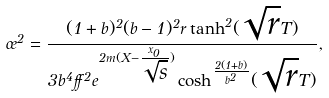<formula> <loc_0><loc_0><loc_500><loc_500>\sigma ^ { 2 } = \frac { ( 1 + b ) ^ { 2 } ( b - 1 ) ^ { 2 } r \tanh ^ { 2 } ( \sqrt { r } T ) } { 3 b ^ { 4 } \alpha ^ { 2 } e ^ { 2 m ( X - \frac { x _ { 0 } } { \sqrt { s } } ) } \cosh ^ { \frac { 2 ( 1 + b ) } { b ^ { 2 } } } ( \sqrt { r } T ) } ,</formula> 